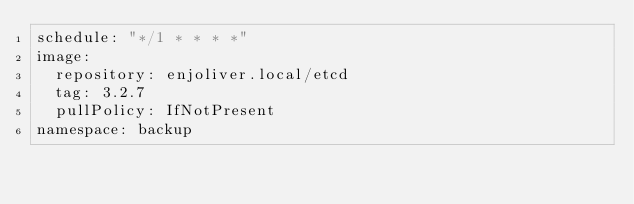<code> <loc_0><loc_0><loc_500><loc_500><_YAML_>schedule: "*/1 * * * *"
image:
  repository: enjoliver.local/etcd
  tag: 3.2.7
  pullPolicy: IfNotPresent
namespace: backup</code> 